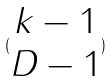<formula> <loc_0><loc_0><loc_500><loc_500>( \begin{matrix} k - 1 \\ D - 1 \end{matrix} )</formula> 